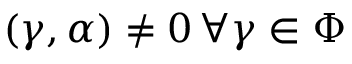<formula> <loc_0><loc_0><loc_500><loc_500>( \gamma , \alpha ) \neq 0 \, \forall \gamma \in \Phi</formula> 